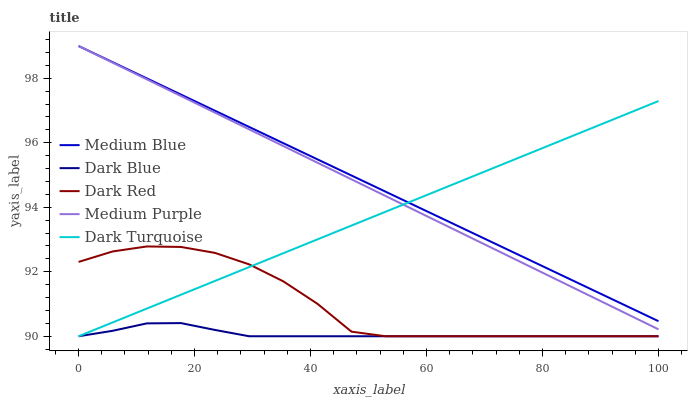Does Dark Blue have the minimum area under the curve?
Answer yes or no. Yes. Does Medium Blue have the maximum area under the curve?
Answer yes or no. Yes. Does Medium Blue have the minimum area under the curve?
Answer yes or no. No. Does Dark Blue have the maximum area under the curve?
Answer yes or no. No. Is Dark Turquoise the smoothest?
Answer yes or no. Yes. Is Dark Red the roughest?
Answer yes or no. Yes. Is Dark Blue the smoothest?
Answer yes or no. No. Is Dark Blue the roughest?
Answer yes or no. No. Does Dark Blue have the lowest value?
Answer yes or no. Yes. Does Medium Blue have the lowest value?
Answer yes or no. No. Does Medium Blue have the highest value?
Answer yes or no. Yes. Does Dark Blue have the highest value?
Answer yes or no. No. Is Dark Red less than Medium Blue?
Answer yes or no. Yes. Is Medium Purple greater than Dark Red?
Answer yes or no. Yes. Does Dark Turquoise intersect Dark Red?
Answer yes or no. Yes. Is Dark Turquoise less than Dark Red?
Answer yes or no. No. Is Dark Turquoise greater than Dark Red?
Answer yes or no. No. Does Dark Red intersect Medium Blue?
Answer yes or no. No. 